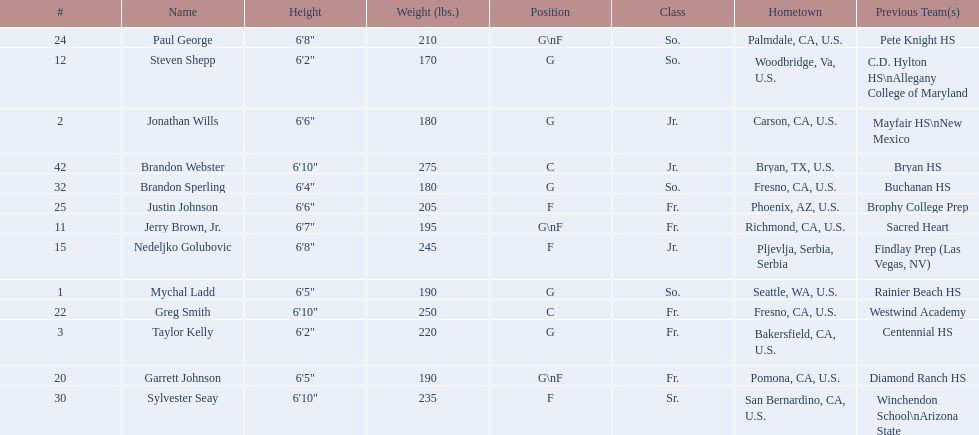What are the names of the basketball team players? Mychal Ladd, Jonathan Wills, Taylor Kelly, Jerry Brown, Jr., Steven Shepp, Nedeljko Golubovic, Garrett Johnson, Greg Smith, Paul George, Justin Johnson, Sylvester Seay, Brandon Sperling, Brandon Webster. Of these identify paul george and greg smith Greg Smith, Paul George. What are their corresponding heights? 6'10", 6'8". To who does the larger height correspond to? Greg Smith. 